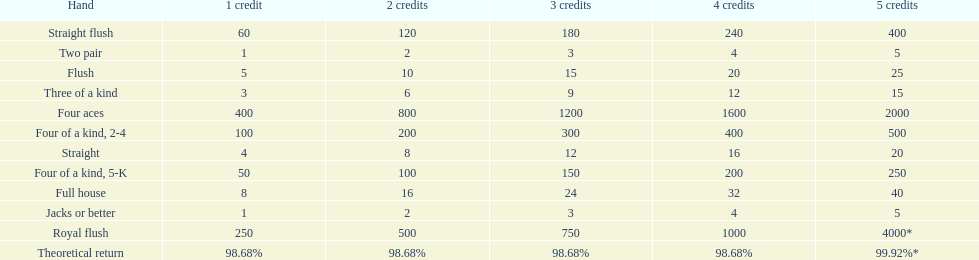What are the top 5 best types of hand for winning? Royal flush, Straight flush, Four aces, Four of a kind, 2-4, Four of a kind, 5-K. Between those 5, which of those hands are four of a kind? Four of a kind, 2-4, Four of a kind, 5-K. Of those 2 hands, which is the best kind of four of a kind for winning? Four of a kind, 2-4. 